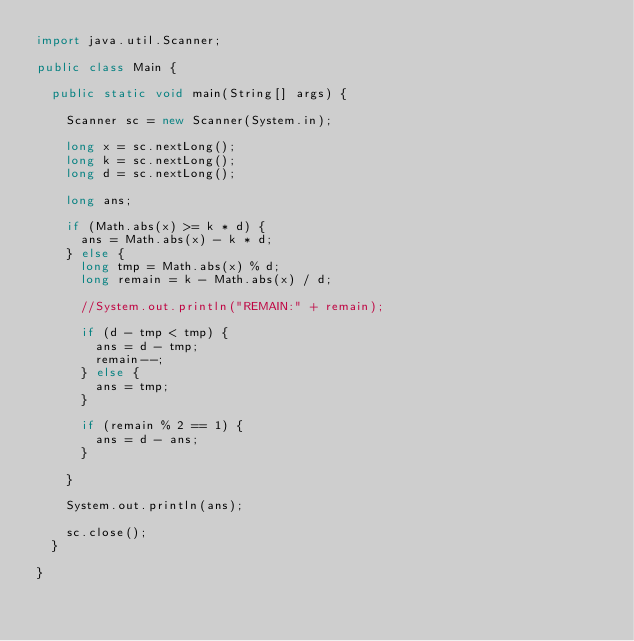Convert code to text. <code><loc_0><loc_0><loc_500><loc_500><_Java_>import java.util.Scanner;

public class Main {

	public static void main(String[] args) {

		Scanner sc = new Scanner(System.in);

		long x = sc.nextLong();
		long k = sc.nextLong();
		long d = sc.nextLong();

		long ans;

		if (Math.abs(x) >= k * d) {
			ans = Math.abs(x) - k * d;
		} else {
			long tmp = Math.abs(x) % d;
			long remain = k - Math.abs(x) / d;

			//System.out.println("REMAIN:" + remain);

			if (d - tmp < tmp) {
				ans = d - tmp;
				remain--;
			} else {
				ans = tmp;
			}

			if (remain % 2 == 1) {
				ans = d - ans;
			}

		}

		System.out.println(ans);

		sc.close();
	}

}</code> 